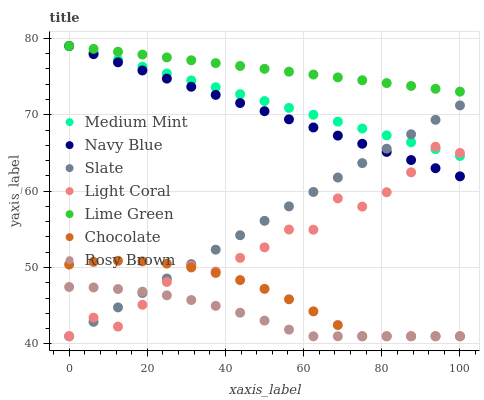Does Rosy Brown have the minimum area under the curve?
Answer yes or no. Yes. Does Lime Green have the maximum area under the curve?
Answer yes or no. Yes. Does Navy Blue have the minimum area under the curve?
Answer yes or no. No. Does Navy Blue have the maximum area under the curve?
Answer yes or no. No. Is Medium Mint the smoothest?
Answer yes or no. Yes. Is Light Coral the roughest?
Answer yes or no. Yes. Is Navy Blue the smoothest?
Answer yes or no. No. Is Navy Blue the roughest?
Answer yes or no. No. Does Slate have the lowest value?
Answer yes or no. Yes. Does Navy Blue have the lowest value?
Answer yes or no. No. Does Lime Green have the highest value?
Answer yes or no. Yes. Does Slate have the highest value?
Answer yes or no. No. Is Rosy Brown less than Navy Blue?
Answer yes or no. Yes. Is Medium Mint greater than Chocolate?
Answer yes or no. Yes. Does Light Coral intersect Slate?
Answer yes or no. Yes. Is Light Coral less than Slate?
Answer yes or no. No. Is Light Coral greater than Slate?
Answer yes or no. No. Does Rosy Brown intersect Navy Blue?
Answer yes or no. No. 